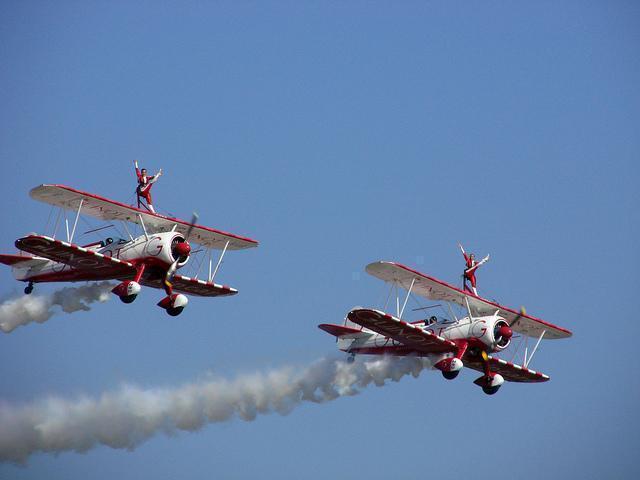What profession do the people on top of the planes belong to?
Choose the correct response, then elucidate: 'Answer: answer
Rationale: rationale.'
Options: Acrobats, teachers, lion tamers, pilots. Answer: acrobats.
Rationale: The profession is acrobatics. 